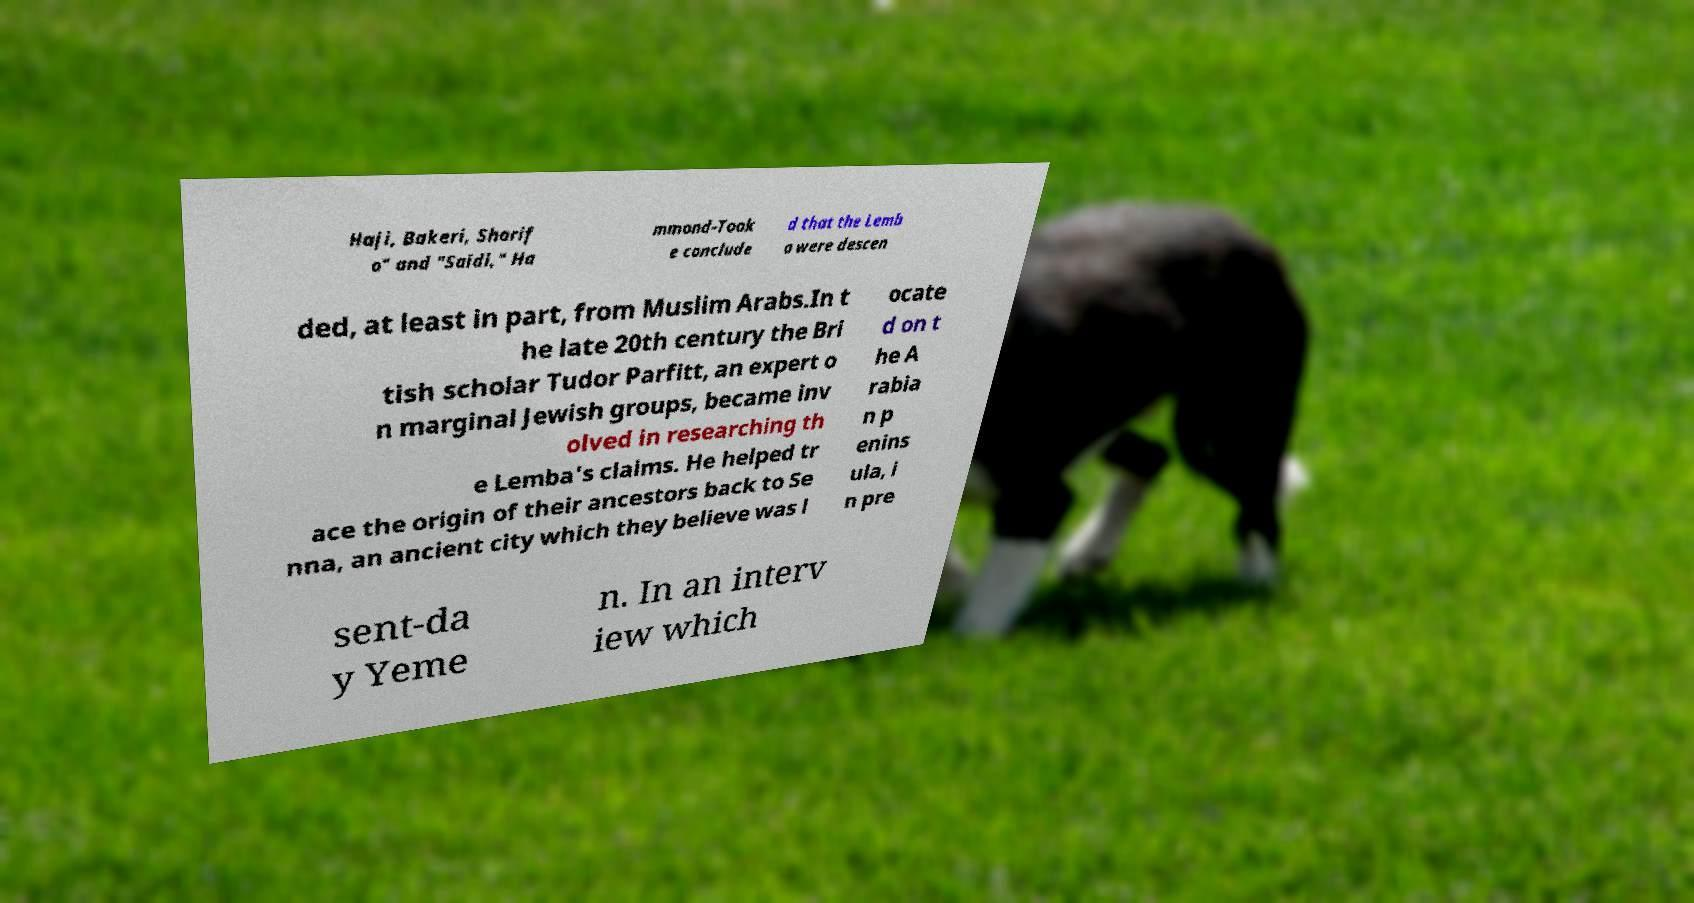What messages or text are displayed in this image? I need them in a readable, typed format. Haji, Bakeri, Sharif o" and "Saidi," Ha mmond-Took e conclude d that the Lemb a were descen ded, at least in part, from Muslim Arabs.In t he late 20th century the Bri tish scholar Tudor Parfitt, an expert o n marginal Jewish groups, became inv olved in researching th e Lemba's claims. He helped tr ace the origin of their ancestors back to Se nna, an ancient city which they believe was l ocate d on t he A rabia n p enins ula, i n pre sent-da y Yeme n. In an interv iew which 